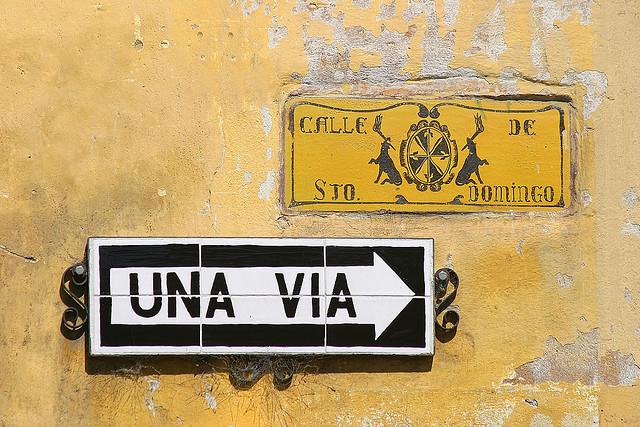How many signs are there?
Concise answer only. 2. What language is this One Way sign in?
Answer briefly. Spanish. Can a car turn left onto this road?
Short answer required. No. 